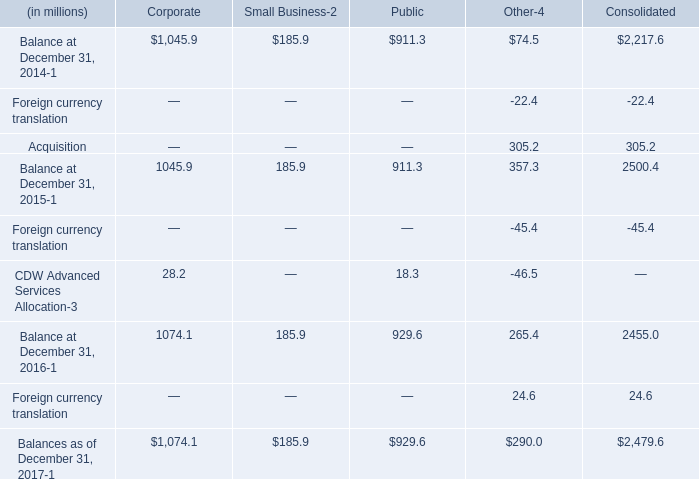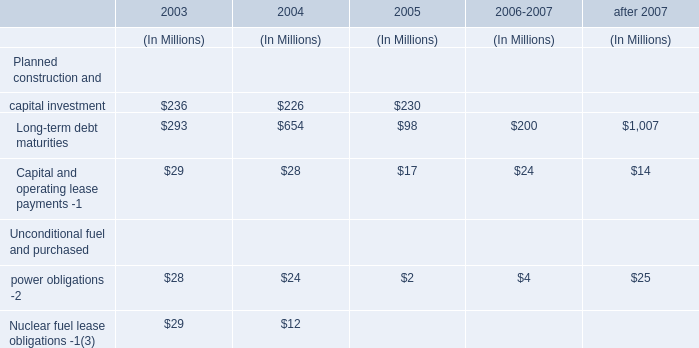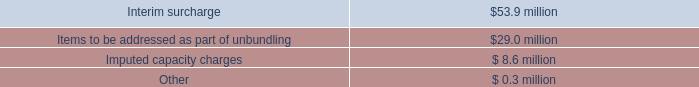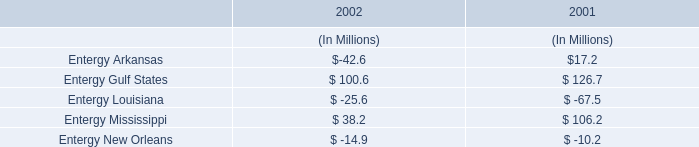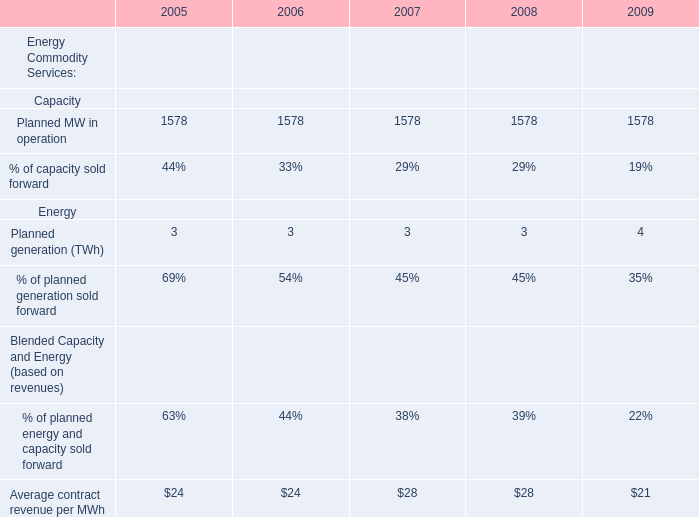What's the sum of Planned MW in operation of 2009, and Balance at December 31, 2014 of Corporate ? 
Computations: (1578.0 + 1045.9)
Answer: 2623.9. 